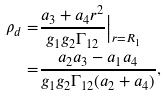<formula> <loc_0><loc_0><loc_500><loc_500>\rho _ { d } = & \frac { a _ { 3 } + a _ { 4 } r ^ { 2 } } { g _ { 1 } g _ { 2 } \Gamma _ { 1 2 } } \Big | _ { r = R _ { 1 } } \\ = & \frac { a _ { 2 } a _ { 3 } - a _ { 1 } a _ { 4 } } { g _ { 1 } g _ { 2 } \Gamma _ { 1 2 } ( a _ { 2 } + a _ { 4 } ) } ,</formula> 